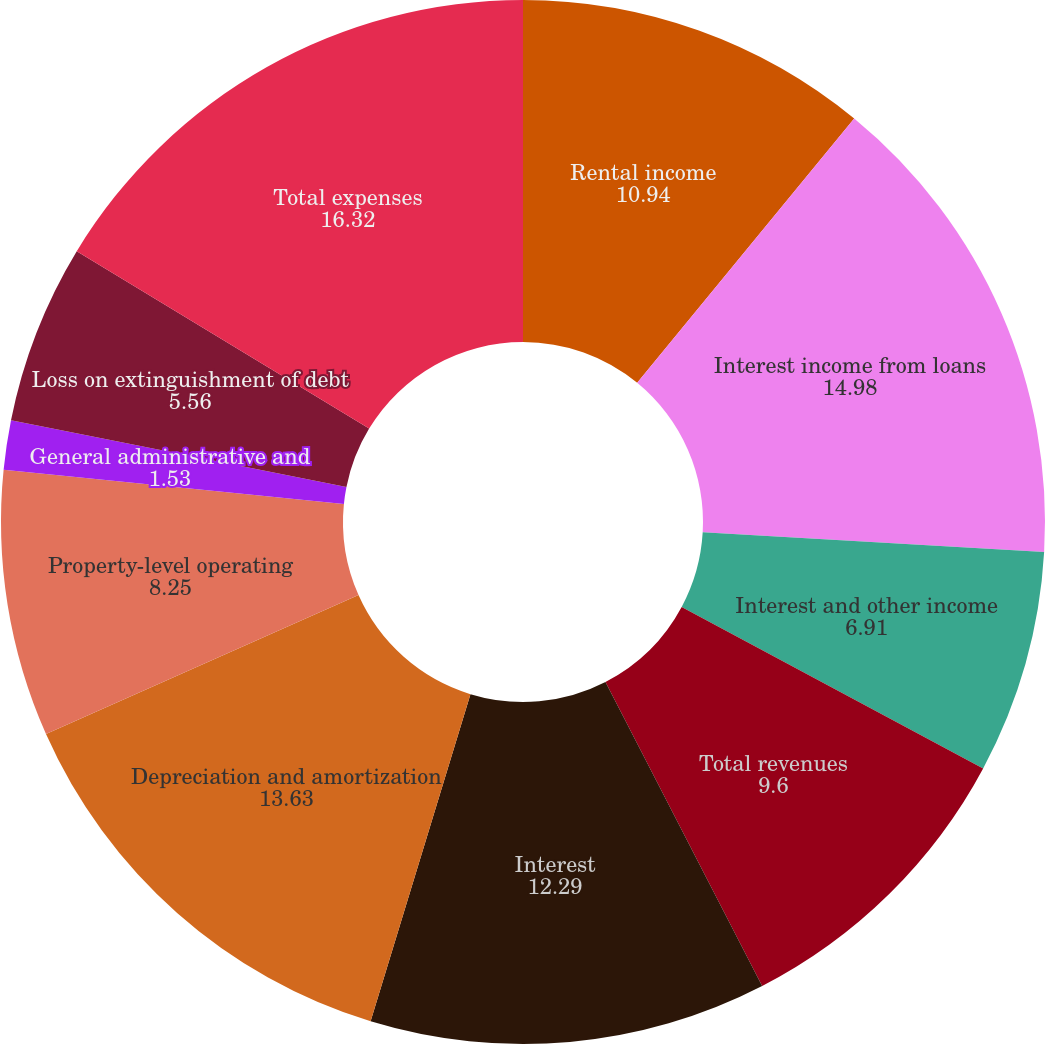Convert chart. <chart><loc_0><loc_0><loc_500><loc_500><pie_chart><fcel>Rental income<fcel>Interest income from loans<fcel>Interest and other income<fcel>Total revenues<fcel>Interest<fcel>Depreciation and amortization<fcel>Property-level operating<fcel>General administrative and<fcel>Loss on extinguishment of debt<fcel>Total expenses<nl><fcel>10.94%<fcel>14.98%<fcel>6.91%<fcel>9.6%<fcel>12.29%<fcel>13.63%<fcel>8.25%<fcel>1.53%<fcel>5.56%<fcel>16.32%<nl></chart> 